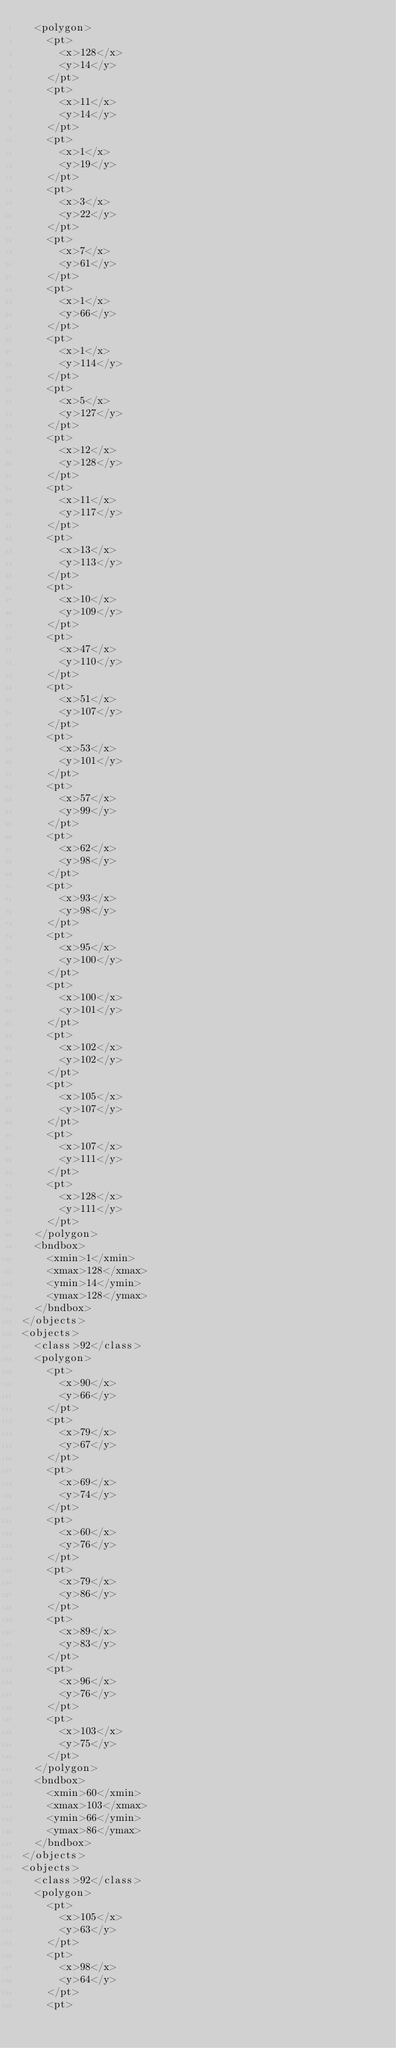<code> <loc_0><loc_0><loc_500><loc_500><_XML_>	<polygon>
		<pt>
			<x>128</x>
			<y>14</y>
		</pt>
		<pt>
			<x>11</x>
			<y>14</y>
		</pt>
		<pt>
			<x>1</x>
			<y>19</y>
		</pt>
		<pt>
			<x>3</x>
			<y>22</y>
		</pt>
		<pt>
			<x>7</x>
			<y>61</y>
		</pt>
		<pt>
			<x>1</x>
			<y>66</y>
		</pt>
		<pt>
			<x>1</x>
			<y>114</y>
		</pt>
		<pt>
			<x>5</x>
			<y>127</y>
		</pt>
		<pt>
			<x>12</x>
			<y>128</y>
		</pt>
		<pt>
			<x>11</x>
			<y>117</y>
		</pt>
		<pt>
			<x>13</x>
			<y>113</y>
		</pt>
		<pt>
			<x>10</x>
			<y>109</y>
		</pt>
		<pt>
			<x>47</x>
			<y>110</y>
		</pt>
		<pt>
			<x>51</x>
			<y>107</y>
		</pt>
		<pt>
			<x>53</x>
			<y>101</y>
		</pt>
		<pt>
			<x>57</x>
			<y>99</y>
		</pt>
		<pt>
			<x>62</x>
			<y>98</y>
		</pt>
		<pt>
			<x>93</x>
			<y>98</y>
		</pt>
		<pt>
			<x>95</x>
			<y>100</y>
		</pt>
		<pt>
			<x>100</x>
			<y>101</y>
		</pt>
		<pt>
			<x>102</x>
			<y>102</y>
		</pt>
		<pt>
			<x>105</x>
			<y>107</y>
		</pt>
		<pt>
			<x>107</x>
			<y>111</y>
		</pt>
		<pt>
			<x>128</x>
			<y>111</y>
		</pt>
	</polygon>
	<bndbox>
		<xmin>1</xmin>
		<xmax>128</xmax>
		<ymin>14</ymin>
		<ymax>128</ymax>
	</bndbox>
</objects>
<objects>
	<class>92</class>
	<polygon>
		<pt>
			<x>90</x>
			<y>66</y>
		</pt>
		<pt>
			<x>79</x>
			<y>67</y>
		</pt>
		<pt>
			<x>69</x>
			<y>74</y>
		</pt>
		<pt>
			<x>60</x>
			<y>76</y>
		</pt>
		<pt>
			<x>79</x>
			<y>86</y>
		</pt>
		<pt>
			<x>89</x>
			<y>83</y>
		</pt>
		<pt>
			<x>96</x>
			<y>76</y>
		</pt>
		<pt>
			<x>103</x>
			<y>75</y>
		</pt>
	</polygon>
	<bndbox>
		<xmin>60</xmin>
		<xmax>103</xmax>
		<ymin>66</ymin>
		<ymax>86</ymax>
	</bndbox>
</objects>
<objects>
	<class>92</class>
	<polygon>
		<pt>
			<x>105</x>
			<y>63</y>
		</pt>
		<pt>
			<x>98</x>
			<y>64</y>
		</pt>
		<pt></code> 